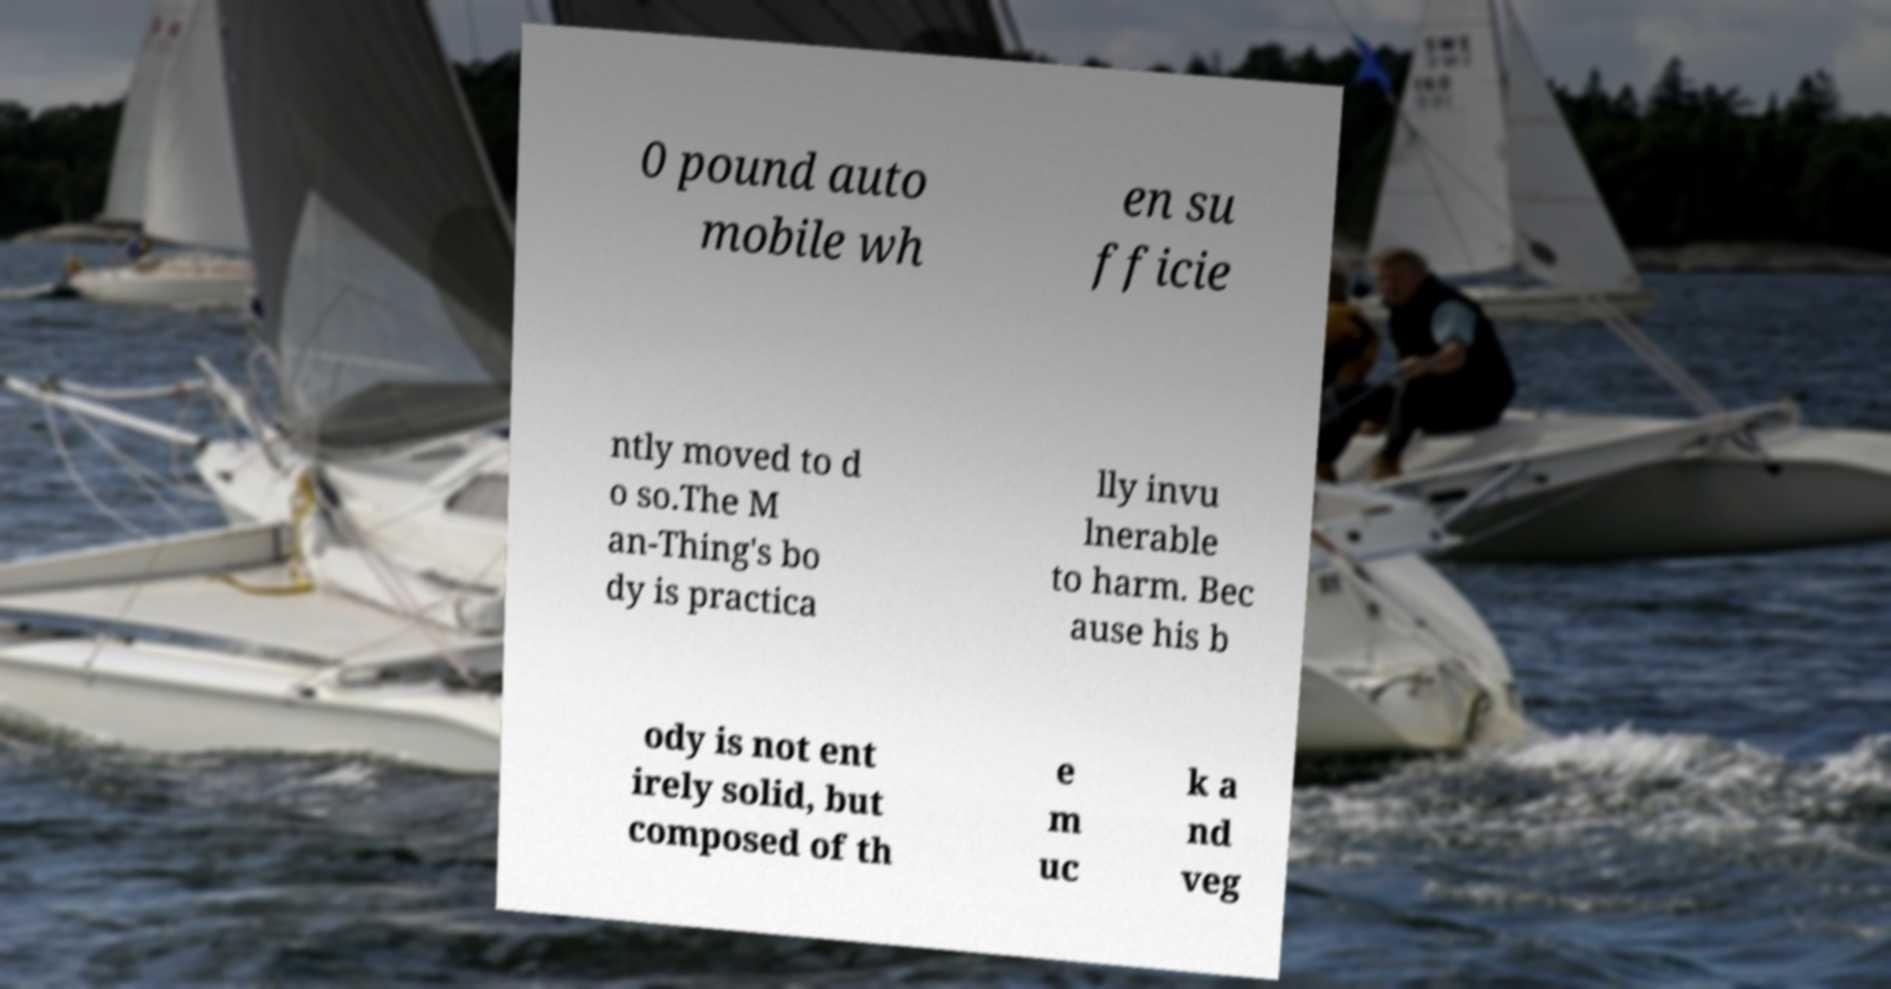What messages or text are displayed in this image? I need them in a readable, typed format. 0 pound auto mobile wh en su fficie ntly moved to d o so.The M an-Thing's bo dy is practica lly invu lnerable to harm. Bec ause his b ody is not ent irely solid, but composed of th e m uc k a nd veg 